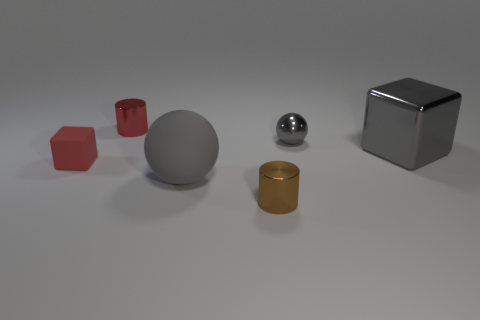Add 4 tiny gray metal things. How many objects exist? 10 Subtract all balls. How many objects are left? 4 Add 5 cubes. How many cubes exist? 7 Subtract 0 red balls. How many objects are left? 6 Subtract all big gray matte things. Subtract all red cylinders. How many objects are left? 4 Add 3 gray metallic balls. How many gray metallic balls are left? 4 